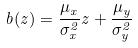<formula> <loc_0><loc_0><loc_500><loc_500>b ( z ) = \frac { \mu _ { x } } { \sigma _ { x } ^ { 2 } } z + \frac { \mu _ { y } } { \sigma _ { y } ^ { 2 } }</formula> 